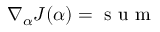<formula> <loc_0><loc_0><loc_500><loc_500>\nabla _ { \alpha } J ( \alpha ) = s u m</formula> 